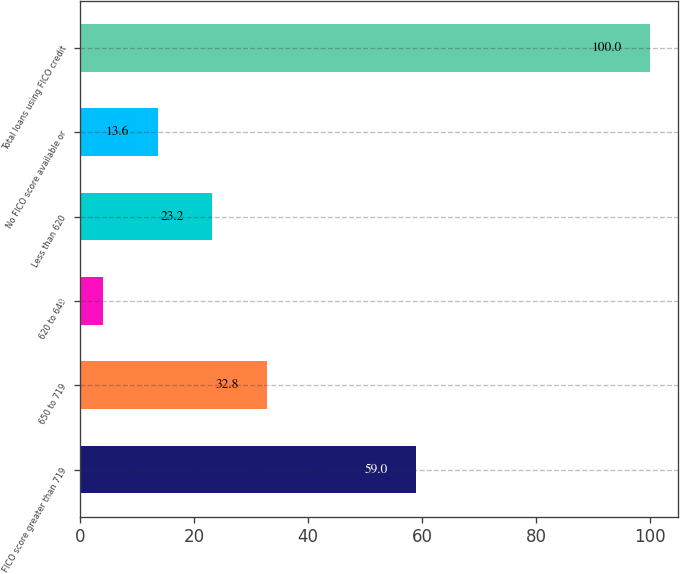Convert chart to OTSL. <chart><loc_0><loc_0><loc_500><loc_500><bar_chart><fcel>FICO score greater than 719<fcel>650 to 719<fcel>620 to 649<fcel>Less than 620<fcel>No FICO score available or<fcel>Total loans using FICO credit<nl><fcel>59<fcel>32.8<fcel>4<fcel>23.2<fcel>13.6<fcel>100<nl></chart> 